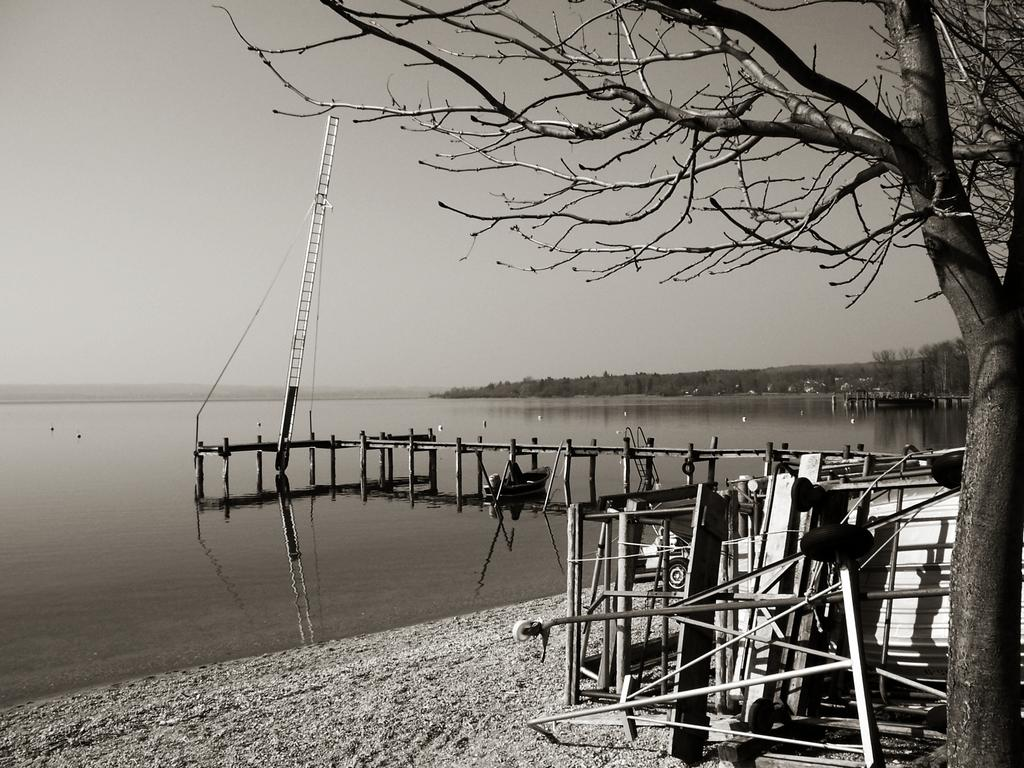What is the primary element present in the image? There is water in the image. What type of natural vegetation can be seen in the image? There are trees in the image. What part of the natural environment is visible in the image? The sky is visible in the image. What can be found on the ground on the right side of the image? There are objects on the ground on the right side of the image. What holiday is being celebrated in the image? There is no indication of a holiday being celebrated in the image. What type of cracker is visible in the image? There is no cracker present in the image. 